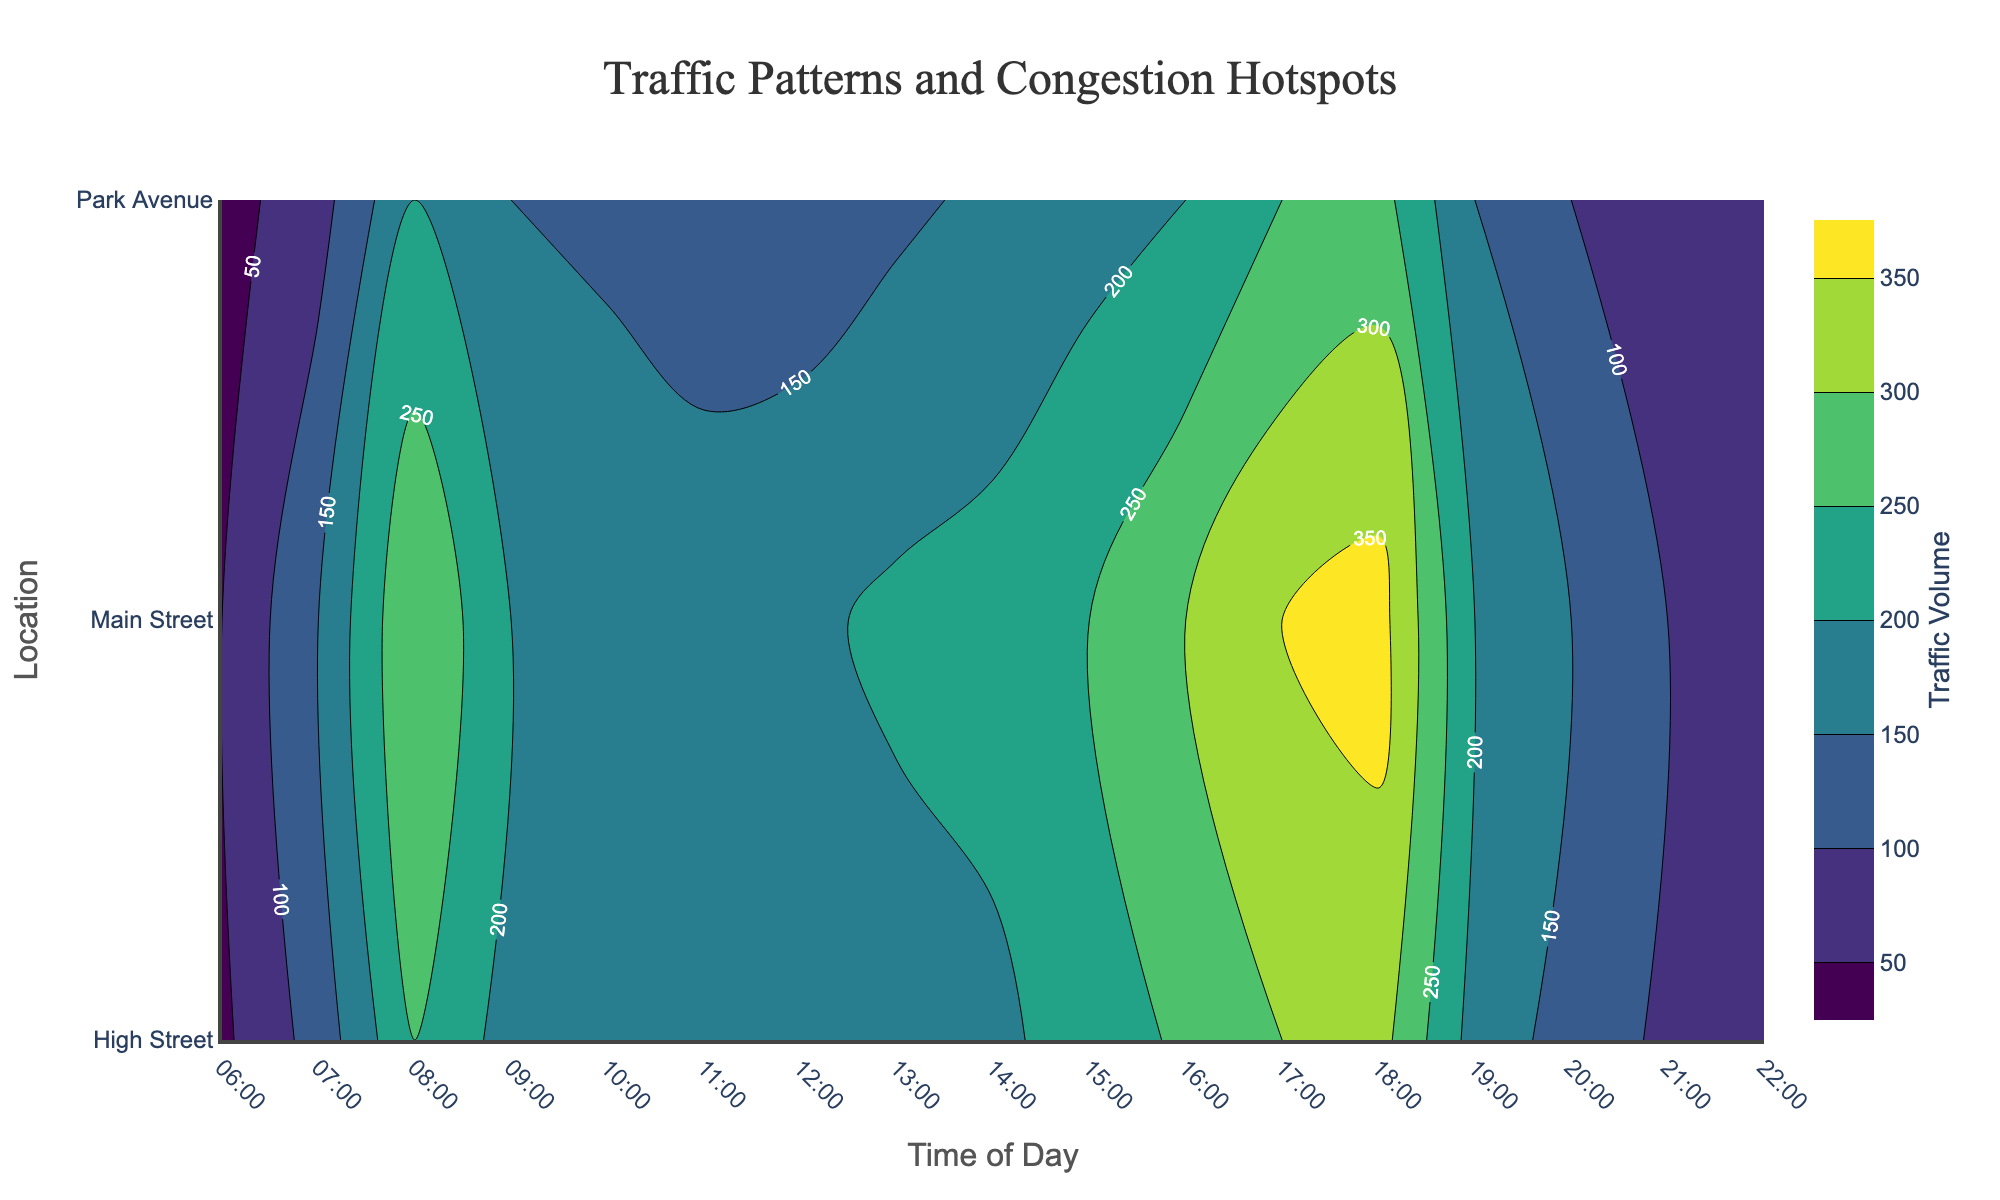What's the title of the figure? The title is displayed prominently at the top of the figure, usually in a larger font size and bold style. Here, it's located at the center of the top area above the plot.
Answer: Traffic Patterns and Congestion Hotspots Which time of the day has the highest traffic volume on Main Street? By observing the contour levels and their labels, we can see the highest values for Main Street's traffic volume. The 18:00 time slot shows the maximum congestion for Main Street.
Answer: 18:00 During which hours does Park Avenue have relatively lower traffic congestion compared to its peak times? Identify the peaks from the contour plot by noting the areas with the darkest colors (highest values). Looking for lighter areas (lower values) helps in identifying lower traffic times. For Park Avenue, traffic is considerably lower before 07:00 and after 20:00.
Answer: Before 07:00 and after 20:00 Compare the traffic volume on High Street at 08:00 and 17:00. Which time has higher congestion? Locate the cross-sections at 08:00 and 17:00 on High Street in the contour plot. The area with higher contour value indicates higher traffic. At 17:00, the traffic volume (300) is higher compared to 08:00 (250).
Answer: 17:00 Which location has the least traffic congestion at 21:00? Examine the contours or values indicated for each location at 21:00. The location with the lowest value at that hour has the least congestion. Park Avenue has a traffic volume of 70, which is the lowest among the three locations at 21:00.
Answer: Park Avenue What general trend can be inferred about traffic volumes on Main Street across the day? By observing the contour levels along Main Street throughout the day, the data show traffic increases in the morning, peaks around 18:00, and then decreases toward the night. This indicates a typical rush hour pattern with higher volumes during morning and evening commute times and lower traffic late at night.
Answer: Morning and evening peak, lower at night Which location experiences the most dramatic increase in traffic volume from 06:00 to 08:00? To determine this, compare the traffic volumes at 06:00 and 08:00 for each location. The increase for each would be: Main Street (300 - 50 = 250), High Street (250 - 40 = 210), Park Avenue (200 - 30 = 170). Main Street shows the most dramatic increase.
Answer: Main Street Is there any point in the day when traffic volumes across all locations are relatively similar? Find time intervals where contour levels for all locations are closely clustered. At 21:00, traffic volumes are 100 (Main Street), 90 (High Street), and 70 (Park Avenue), which are relatively similar compared to other times.
Answer: 21:00 